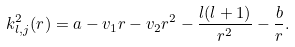Convert formula to latex. <formula><loc_0><loc_0><loc_500><loc_500>k _ { l , j } ^ { 2 } ( r ) = a - v _ { 1 } r - v _ { 2 } r ^ { 2 } - \frac { l ( l + 1 ) } { r ^ { 2 } } - \frac { b } { r } .</formula> 